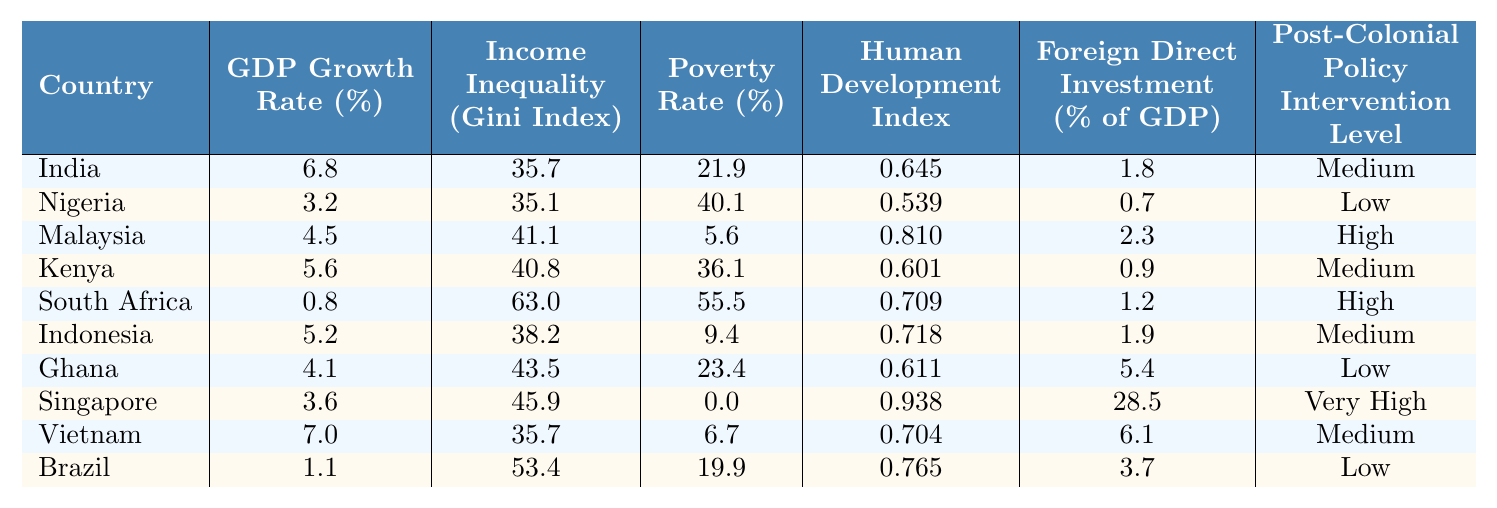What is the GDP growth rate of India? The table shows that the GDP growth rate for India is listed as 6.8%.
Answer: 6.8% Which country has the highest income inequality as measured by the Gini Index? The Gini Index for South Africa is 63.0, which is higher than any other country listed.
Answer: South Africa What is the poverty rate in Ghana? The table indicates that the poverty rate in Ghana is 23.4%.
Answer: 23.4% Which countries have a medium level of post-colonial policy intervention? Referring to the table, the countries categorized with a medium level of intervention are India, Kenya, Indonesia, and Vietnam.
Answer: India, Kenya, Indonesia, Vietnam What is the average GDP growth rate of the countries with low post-colonial policy intervention? The countries with low intervention are Nigeria, Ghana, and Brazil. Their GDP growth rates are 3.2%, 4.1%, and 1.1%, respectively. The sum is 3.2 + 4.1 + 1.1 = 8.4%. Dividing by the number of countries (3), the average is 8.4/3 = 2.8%.
Answer: 2.8% Is the Human Development Index of Malaysia higher than that of Nigeria? The Human Development Index for Malaysia is 0.810, while for Nigeria, it is 0.539. Therefore, yes, Malaysia has a higher Human Development Index.
Answer: Yes Which country with high post-colonial policy intervention has the lowest GDP growth rate? Among the countries with high intervention, South Africa has a GDP growth rate of only 0.8%, which is lower than that of Malaysia (4.5%).
Answer: South Africa What is the difference in the poverty rates between South Africa and Malaysia? South Africa has a poverty rate of 55.5%, while Malaysia's is 5.6%. The difference is 55.5 - 5.6 = 49.9%.
Answer: 49.9% Which country has the highest foreign direct investment as a percentage of GDP? Singapore has the highest foreign direct investment at 28.5% of GDP, higher than all other listed countries.
Answer: Singapore Are there any countries with a poverty rate below 10%? The table shows that Malaysia and Vietnam have poverty rates of 5.6% and 6.7%, respectively, both below 10%.
Answer: Yes 